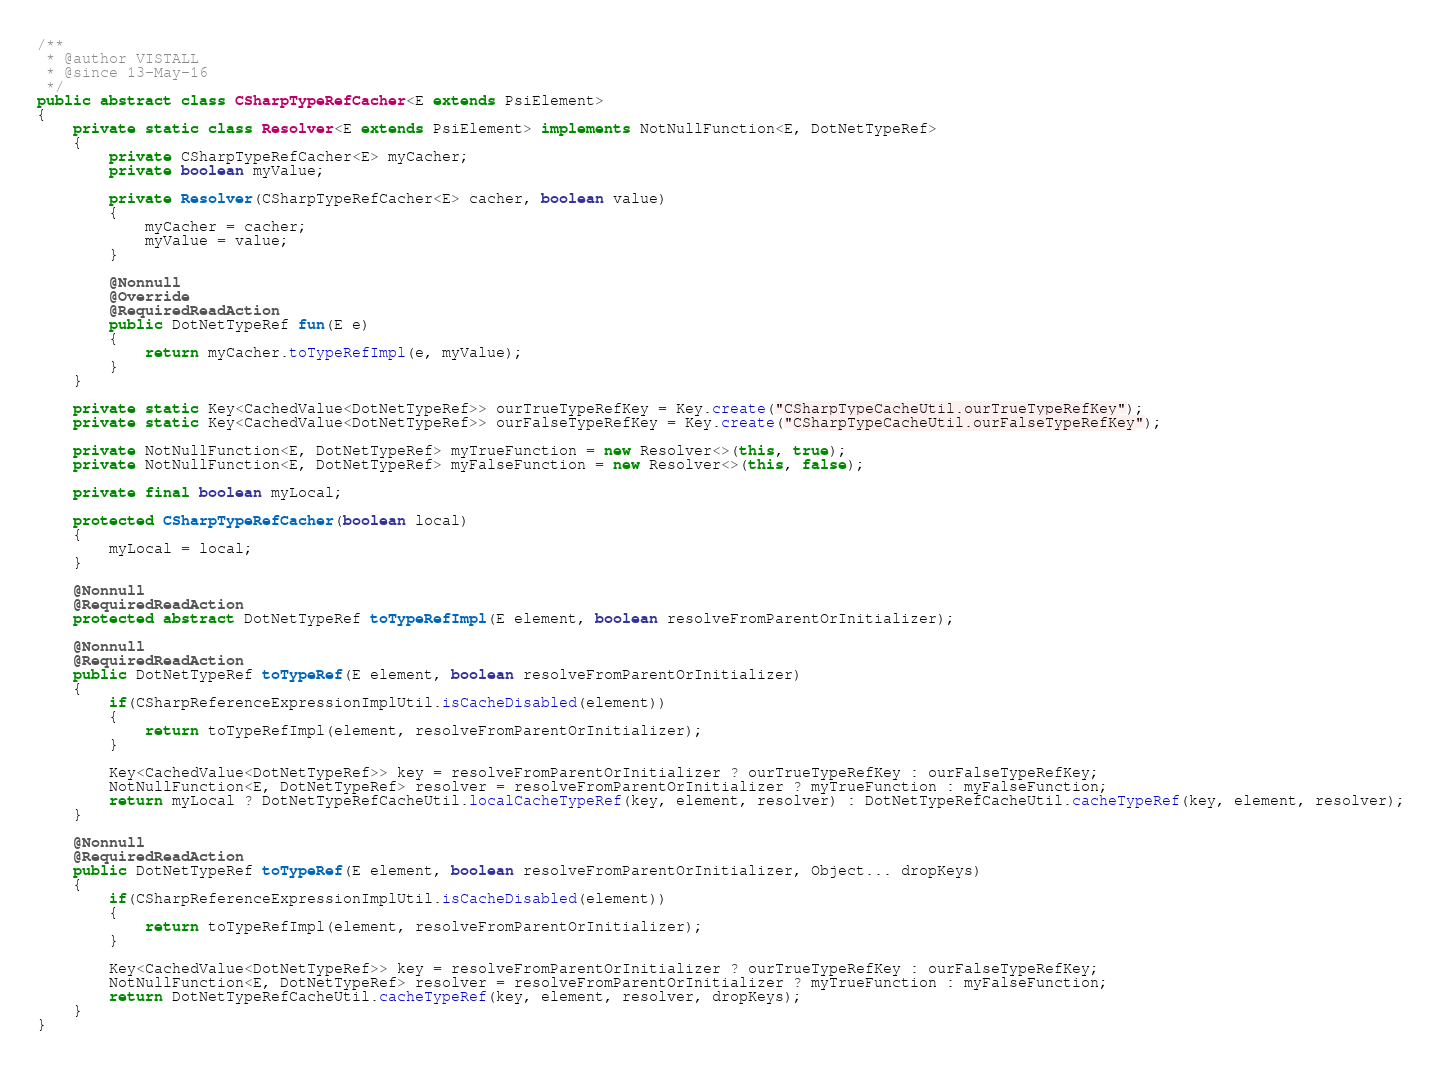<code> <loc_0><loc_0><loc_500><loc_500><_Java_>
/**
 * @author VISTALL
 * @since 13-May-16
 */
public abstract class CSharpTypeRefCacher<E extends PsiElement>
{
	private static class Resolver<E extends PsiElement> implements NotNullFunction<E, DotNetTypeRef>
	{
		private CSharpTypeRefCacher<E> myCacher;
		private boolean myValue;

		private Resolver(CSharpTypeRefCacher<E> cacher, boolean value)
		{
			myCacher = cacher;
			myValue = value;
		}

		@Nonnull
		@Override
		@RequiredReadAction
		public DotNetTypeRef fun(E e)
		{
			return myCacher.toTypeRefImpl(e, myValue);
		}
	}

	private static Key<CachedValue<DotNetTypeRef>> ourTrueTypeRefKey = Key.create("CSharpTypeCacheUtil.ourTrueTypeRefKey");
	private static Key<CachedValue<DotNetTypeRef>> ourFalseTypeRefKey = Key.create("CSharpTypeCacheUtil.ourFalseTypeRefKey");

	private NotNullFunction<E, DotNetTypeRef> myTrueFunction = new Resolver<>(this, true);
	private NotNullFunction<E, DotNetTypeRef> myFalseFunction = new Resolver<>(this, false);

	private final boolean myLocal;

	protected CSharpTypeRefCacher(boolean local)
	{
		myLocal = local;
	}

	@Nonnull
	@RequiredReadAction
	protected abstract DotNetTypeRef toTypeRefImpl(E element, boolean resolveFromParentOrInitializer);

	@Nonnull
	@RequiredReadAction
	public DotNetTypeRef toTypeRef(E element, boolean resolveFromParentOrInitializer)
	{
		if(CSharpReferenceExpressionImplUtil.isCacheDisabled(element))
		{
			return toTypeRefImpl(element, resolveFromParentOrInitializer);
		}

		Key<CachedValue<DotNetTypeRef>> key = resolveFromParentOrInitializer ? ourTrueTypeRefKey : ourFalseTypeRefKey;
		NotNullFunction<E, DotNetTypeRef> resolver = resolveFromParentOrInitializer ? myTrueFunction : myFalseFunction;
		return myLocal ? DotNetTypeRefCacheUtil.localCacheTypeRef(key, element, resolver) : DotNetTypeRefCacheUtil.cacheTypeRef(key, element, resolver);
	}

	@Nonnull
	@RequiredReadAction
	public DotNetTypeRef toTypeRef(E element, boolean resolveFromParentOrInitializer, Object... dropKeys)
	{
		if(CSharpReferenceExpressionImplUtil.isCacheDisabled(element))
		{
			return toTypeRefImpl(element, resolveFromParentOrInitializer);
		}

		Key<CachedValue<DotNetTypeRef>> key = resolveFromParentOrInitializer ? ourTrueTypeRefKey : ourFalseTypeRefKey;
		NotNullFunction<E, DotNetTypeRef> resolver = resolveFromParentOrInitializer ? myTrueFunction : myFalseFunction;
		return DotNetTypeRefCacheUtil.cacheTypeRef(key, element, resolver, dropKeys);
	}
}
</code> 